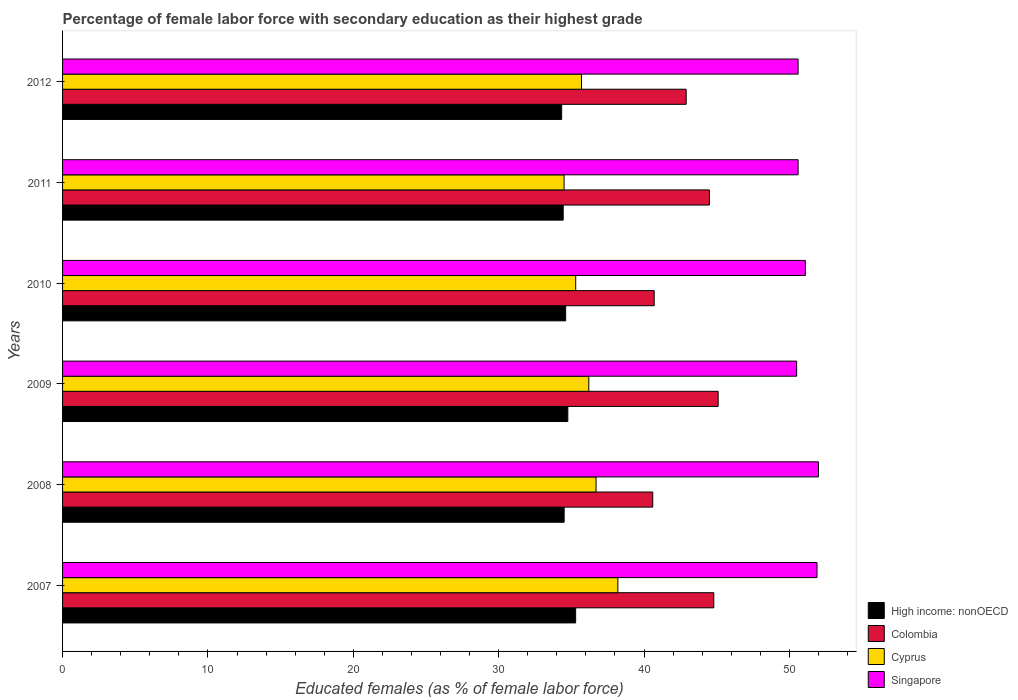How many different coloured bars are there?
Make the answer very short. 4. How many groups of bars are there?
Offer a very short reply. 6. Are the number of bars on each tick of the Y-axis equal?
Provide a short and direct response. Yes. How many bars are there on the 3rd tick from the top?
Your response must be concise. 4. What is the percentage of female labor force with secondary education in Colombia in 2011?
Keep it short and to the point. 44.5. Across all years, what is the maximum percentage of female labor force with secondary education in Colombia?
Provide a short and direct response. 45.1. Across all years, what is the minimum percentage of female labor force with secondary education in High income: nonOECD?
Provide a succinct answer. 34.33. In which year was the percentage of female labor force with secondary education in High income: nonOECD minimum?
Provide a short and direct response. 2012. What is the total percentage of female labor force with secondary education in Cyprus in the graph?
Your response must be concise. 216.6. What is the difference between the percentage of female labor force with secondary education in Cyprus in 2011 and that in 2012?
Offer a very short reply. -1.2. What is the difference between the percentage of female labor force with secondary education in Colombia in 2011 and the percentage of female labor force with secondary education in Singapore in 2007?
Your answer should be compact. -7.4. What is the average percentage of female labor force with secondary education in Colombia per year?
Your response must be concise. 43.1. In the year 2009, what is the difference between the percentage of female labor force with secondary education in Singapore and percentage of female labor force with secondary education in High income: nonOECD?
Ensure brevity in your answer.  15.74. What is the ratio of the percentage of female labor force with secondary education in High income: nonOECD in 2008 to that in 2012?
Your answer should be compact. 1. Is the difference between the percentage of female labor force with secondary education in Singapore in 2009 and 2010 greater than the difference between the percentage of female labor force with secondary education in High income: nonOECD in 2009 and 2010?
Offer a terse response. No. What is the difference between the highest and the second highest percentage of female labor force with secondary education in High income: nonOECD?
Provide a succinct answer. 0.54. In how many years, is the percentage of female labor force with secondary education in Colombia greater than the average percentage of female labor force with secondary education in Colombia taken over all years?
Your answer should be very brief. 3. Is it the case that in every year, the sum of the percentage of female labor force with secondary education in High income: nonOECD and percentage of female labor force with secondary education in Colombia is greater than the sum of percentage of female labor force with secondary education in Cyprus and percentage of female labor force with secondary education in Singapore?
Your response must be concise. Yes. What does the 3rd bar from the top in 2009 represents?
Ensure brevity in your answer.  Colombia. What does the 4th bar from the bottom in 2012 represents?
Give a very brief answer. Singapore. Is it the case that in every year, the sum of the percentage of female labor force with secondary education in Singapore and percentage of female labor force with secondary education in Colombia is greater than the percentage of female labor force with secondary education in Cyprus?
Ensure brevity in your answer.  Yes. How many bars are there?
Offer a very short reply. 24. Does the graph contain any zero values?
Your answer should be very brief. No. Does the graph contain grids?
Offer a terse response. No. How many legend labels are there?
Offer a very short reply. 4. What is the title of the graph?
Keep it short and to the point. Percentage of female labor force with secondary education as their highest grade. Does "Isle of Man" appear as one of the legend labels in the graph?
Provide a short and direct response. No. What is the label or title of the X-axis?
Provide a succinct answer. Educated females (as % of female labor force). What is the label or title of the Y-axis?
Your answer should be very brief. Years. What is the Educated females (as % of female labor force) of High income: nonOECD in 2007?
Give a very brief answer. 35.3. What is the Educated females (as % of female labor force) in Colombia in 2007?
Offer a very short reply. 44.8. What is the Educated females (as % of female labor force) in Cyprus in 2007?
Provide a short and direct response. 38.2. What is the Educated females (as % of female labor force) in Singapore in 2007?
Ensure brevity in your answer.  51.9. What is the Educated females (as % of female labor force) of High income: nonOECD in 2008?
Offer a terse response. 34.51. What is the Educated females (as % of female labor force) of Colombia in 2008?
Provide a short and direct response. 40.6. What is the Educated females (as % of female labor force) in Cyprus in 2008?
Offer a terse response. 36.7. What is the Educated females (as % of female labor force) of Singapore in 2008?
Your answer should be compact. 52. What is the Educated females (as % of female labor force) in High income: nonOECD in 2009?
Give a very brief answer. 34.76. What is the Educated females (as % of female labor force) of Colombia in 2009?
Provide a succinct answer. 45.1. What is the Educated females (as % of female labor force) of Cyprus in 2009?
Your response must be concise. 36.2. What is the Educated females (as % of female labor force) in Singapore in 2009?
Keep it short and to the point. 50.5. What is the Educated females (as % of female labor force) of High income: nonOECD in 2010?
Give a very brief answer. 34.61. What is the Educated females (as % of female labor force) of Colombia in 2010?
Offer a terse response. 40.7. What is the Educated females (as % of female labor force) in Cyprus in 2010?
Your answer should be very brief. 35.3. What is the Educated females (as % of female labor force) in Singapore in 2010?
Keep it short and to the point. 51.1. What is the Educated females (as % of female labor force) in High income: nonOECD in 2011?
Ensure brevity in your answer.  34.44. What is the Educated females (as % of female labor force) in Colombia in 2011?
Offer a very short reply. 44.5. What is the Educated females (as % of female labor force) of Cyprus in 2011?
Offer a very short reply. 34.5. What is the Educated females (as % of female labor force) in Singapore in 2011?
Your response must be concise. 50.6. What is the Educated females (as % of female labor force) in High income: nonOECD in 2012?
Offer a very short reply. 34.33. What is the Educated females (as % of female labor force) in Colombia in 2012?
Provide a succinct answer. 42.9. What is the Educated females (as % of female labor force) of Cyprus in 2012?
Provide a short and direct response. 35.7. What is the Educated females (as % of female labor force) in Singapore in 2012?
Make the answer very short. 50.6. Across all years, what is the maximum Educated females (as % of female labor force) of High income: nonOECD?
Your answer should be very brief. 35.3. Across all years, what is the maximum Educated females (as % of female labor force) in Colombia?
Give a very brief answer. 45.1. Across all years, what is the maximum Educated females (as % of female labor force) of Cyprus?
Your answer should be compact. 38.2. Across all years, what is the maximum Educated females (as % of female labor force) in Singapore?
Offer a terse response. 52. Across all years, what is the minimum Educated females (as % of female labor force) in High income: nonOECD?
Ensure brevity in your answer.  34.33. Across all years, what is the minimum Educated females (as % of female labor force) of Colombia?
Provide a succinct answer. 40.6. Across all years, what is the minimum Educated females (as % of female labor force) in Cyprus?
Make the answer very short. 34.5. Across all years, what is the minimum Educated females (as % of female labor force) of Singapore?
Make the answer very short. 50.5. What is the total Educated females (as % of female labor force) in High income: nonOECD in the graph?
Make the answer very short. 207.94. What is the total Educated females (as % of female labor force) of Colombia in the graph?
Your answer should be very brief. 258.6. What is the total Educated females (as % of female labor force) in Cyprus in the graph?
Your response must be concise. 216.6. What is the total Educated females (as % of female labor force) of Singapore in the graph?
Give a very brief answer. 306.7. What is the difference between the Educated females (as % of female labor force) in High income: nonOECD in 2007 and that in 2008?
Your answer should be very brief. 0.79. What is the difference between the Educated females (as % of female labor force) of Cyprus in 2007 and that in 2008?
Provide a short and direct response. 1.5. What is the difference between the Educated females (as % of female labor force) of Singapore in 2007 and that in 2008?
Give a very brief answer. -0.1. What is the difference between the Educated females (as % of female labor force) of High income: nonOECD in 2007 and that in 2009?
Provide a short and direct response. 0.54. What is the difference between the Educated females (as % of female labor force) in Cyprus in 2007 and that in 2009?
Offer a very short reply. 2. What is the difference between the Educated females (as % of female labor force) of High income: nonOECD in 2007 and that in 2010?
Give a very brief answer. 0.69. What is the difference between the Educated females (as % of female labor force) of Colombia in 2007 and that in 2010?
Offer a very short reply. 4.1. What is the difference between the Educated females (as % of female labor force) of Cyprus in 2007 and that in 2010?
Provide a short and direct response. 2.9. What is the difference between the Educated females (as % of female labor force) of High income: nonOECD in 2007 and that in 2011?
Make the answer very short. 0.86. What is the difference between the Educated females (as % of female labor force) of High income: nonOECD in 2007 and that in 2012?
Keep it short and to the point. 0.96. What is the difference between the Educated females (as % of female labor force) in Colombia in 2007 and that in 2012?
Your answer should be very brief. 1.9. What is the difference between the Educated females (as % of female labor force) of High income: nonOECD in 2008 and that in 2009?
Ensure brevity in your answer.  -0.25. What is the difference between the Educated females (as % of female labor force) in Colombia in 2008 and that in 2009?
Offer a very short reply. -4.5. What is the difference between the Educated females (as % of female labor force) in Cyprus in 2008 and that in 2009?
Offer a very short reply. 0.5. What is the difference between the Educated females (as % of female labor force) in High income: nonOECD in 2008 and that in 2010?
Provide a succinct answer. -0.11. What is the difference between the Educated females (as % of female labor force) in Colombia in 2008 and that in 2010?
Your answer should be very brief. -0.1. What is the difference between the Educated females (as % of female labor force) in Singapore in 2008 and that in 2010?
Offer a very short reply. 0.9. What is the difference between the Educated females (as % of female labor force) in High income: nonOECD in 2008 and that in 2011?
Provide a succinct answer. 0.07. What is the difference between the Educated females (as % of female labor force) of Colombia in 2008 and that in 2011?
Your response must be concise. -3.9. What is the difference between the Educated females (as % of female labor force) in Singapore in 2008 and that in 2011?
Provide a succinct answer. 1.4. What is the difference between the Educated females (as % of female labor force) in High income: nonOECD in 2008 and that in 2012?
Ensure brevity in your answer.  0.17. What is the difference between the Educated females (as % of female labor force) of Colombia in 2008 and that in 2012?
Offer a very short reply. -2.3. What is the difference between the Educated females (as % of female labor force) of Cyprus in 2008 and that in 2012?
Offer a terse response. 1. What is the difference between the Educated females (as % of female labor force) of Singapore in 2008 and that in 2012?
Provide a short and direct response. 1.4. What is the difference between the Educated females (as % of female labor force) of High income: nonOECD in 2009 and that in 2010?
Provide a short and direct response. 0.15. What is the difference between the Educated females (as % of female labor force) in Colombia in 2009 and that in 2010?
Offer a very short reply. 4.4. What is the difference between the Educated females (as % of female labor force) in Cyprus in 2009 and that in 2010?
Your answer should be compact. 0.9. What is the difference between the Educated females (as % of female labor force) in High income: nonOECD in 2009 and that in 2011?
Provide a succinct answer. 0.32. What is the difference between the Educated females (as % of female labor force) of Colombia in 2009 and that in 2011?
Your answer should be very brief. 0.6. What is the difference between the Educated females (as % of female labor force) of Cyprus in 2009 and that in 2011?
Offer a terse response. 1.7. What is the difference between the Educated females (as % of female labor force) of High income: nonOECD in 2009 and that in 2012?
Your answer should be very brief. 0.42. What is the difference between the Educated females (as % of female labor force) of Colombia in 2009 and that in 2012?
Offer a terse response. 2.2. What is the difference between the Educated females (as % of female labor force) of Cyprus in 2009 and that in 2012?
Keep it short and to the point. 0.5. What is the difference between the Educated females (as % of female labor force) of Singapore in 2009 and that in 2012?
Give a very brief answer. -0.1. What is the difference between the Educated females (as % of female labor force) in High income: nonOECD in 2010 and that in 2011?
Provide a short and direct response. 0.17. What is the difference between the Educated females (as % of female labor force) in High income: nonOECD in 2010 and that in 2012?
Offer a terse response. 0.28. What is the difference between the Educated females (as % of female labor force) in High income: nonOECD in 2011 and that in 2012?
Give a very brief answer. 0.11. What is the difference between the Educated females (as % of female labor force) of Singapore in 2011 and that in 2012?
Give a very brief answer. 0. What is the difference between the Educated females (as % of female labor force) in High income: nonOECD in 2007 and the Educated females (as % of female labor force) in Colombia in 2008?
Your answer should be very brief. -5.3. What is the difference between the Educated females (as % of female labor force) of High income: nonOECD in 2007 and the Educated females (as % of female labor force) of Cyprus in 2008?
Your answer should be very brief. -1.4. What is the difference between the Educated females (as % of female labor force) of High income: nonOECD in 2007 and the Educated females (as % of female labor force) of Singapore in 2008?
Ensure brevity in your answer.  -16.7. What is the difference between the Educated females (as % of female labor force) of Colombia in 2007 and the Educated females (as % of female labor force) of Singapore in 2008?
Provide a succinct answer. -7.2. What is the difference between the Educated females (as % of female labor force) of Cyprus in 2007 and the Educated females (as % of female labor force) of Singapore in 2008?
Keep it short and to the point. -13.8. What is the difference between the Educated females (as % of female labor force) in High income: nonOECD in 2007 and the Educated females (as % of female labor force) in Colombia in 2009?
Provide a succinct answer. -9.8. What is the difference between the Educated females (as % of female labor force) in High income: nonOECD in 2007 and the Educated females (as % of female labor force) in Cyprus in 2009?
Make the answer very short. -0.9. What is the difference between the Educated females (as % of female labor force) of High income: nonOECD in 2007 and the Educated females (as % of female labor force) of Singapore in 2009?
Your answer should be very brief. -15.2. What is the difference between the Educated females (as % of female labor force) in Colombia in 2007 and the Educated females (as % of female labor force) in Cyprus in 2009?
Ensure brevity in your answer.  8.6. What is the difference between the Educated females (as % of female labor force) of Colombia in 2007 and the Educated females (as % of female labor force) of Singapore in 2009?
Ensure brevity in your answer.  -5.7. What is the difference between the Educated females (as % of female labor force) of High income: nonOECD in 2007 and the Educated females (as % of female labor force) of Colombia in 2010?
Your answer should be compact. -5.4. What is the difference between the Educated females (as % of female labor force) in High income: nonOECD in 2007 and the Educated females (as % of female labor force) in Cyprus in 2010?
Offer a terse response. -0. What is the difference between the Educated females (as % of female labor force) of High income: nonOECD in 2007 and the Educated females (as % of female labor force) of Singapore in 2010?
Your response must be concise. -15.8. What is the difference between the Educated females (as % of female labor force) of Colombia in 2007 and the Educated females (as % of female labor force) of Cyprus in 2010?
Offer a terse response. 9.5. What is the difference between the Educated females (as % of female labor force) of High income: nonOECD in 2007 and the Educated females (as % of female labor force) of Colombia in 2011?
Your response must be concise. -9.2. What is the difference between the Educated females (as % of female labor force) of High income: nonOECD in 2007 and the Educated females (as % of female labor force) of Cyprus in 2011?
Give a very brief answer. 0.8. What is the difference between the Educated females (as % of female labor force) of High income: nonOECD in 2007 and the Educated females (as % of female labor force) of Singapore in 2011?
Keep it short and to the point. -15.3. What is the difference between the Educated females (as % of female labor force) in Colombia in 2007 and the Educated females (as % of female labor force) in Cyprus in 2011?
Keep it short and to the point. 10.3. What is the difference between the Educated females (as % of female labor force) in Colombia in 2007 and the Educated females (as % of female labor force) in Singapore in 2011?
Your response must be concise. -5.8. What is the difference between the Educated females (as % of female labor force) of High income: nonOECD in 2007 and the Educated females (as % of female labor force) of Colombia in 2012?
Offer a terse response. -7.6. What is the difference between the Educated females (as % of female labor force) of High income: nonOECD in 2007 and the Educated females (as % of female labor force) of Cyprus in 2012?
Provide a short and direct response. -0.4. What is the difference between the Educated females (as % of female labor force) in High income: nonOECD in 2007 and the Educated females (as % of female labor force) in Singapore in 2012?
Offer a very short reply. -15.3. What is the difference between the Educated females (as % of female labor force) of Colombia in 2007 and the Educated females (as % of female labor force) of Cyprus in 2012?
Keep it short and to the point. 9.1. What is the difference between the Educated females (as % of female labor force) of High income: nonOECD in 2008 and the Educated females (as % of female labor force) of Colombia in 2009?
Offer a terse response. -10.59. What is the difference between the Educated females (as % of female labor force) of High income: nonOECD in 2008 and the Educated females (as % of female labor force) of Cyprus in 2009?
Make the answer very short. -1.69. What is the difference between the Educated females (as % of female labor force) in High income: nonOECD in 2008 and the Educated females (as % of female labor force) in Singapore in 2009?
Your response must be concise. -15.99. What is the difference between the Educated females (as % of female labor force) in Colombia in 2008 and the Educated females (as % of female labor force) in Singapore in 2009?
Provide a short and direct response. -9.9. What is the difference between the Educated females (as % of female labor force) of High income: nonOECD in 2008 and the Educated females (as % of female labor force) of Colombia in 2010?
Your response must be concise. -6.19. What is the difference between the Educated females (as % of female labor force) of High income: nonOECD in 2008 and the Educated females (as % of female labor force) of Cyprus in 2010?
Offer a very short reply. -0.79. What is the difference between the Educated females (as % of female labor force) in High income: nonOECD in 2008 and the Educated females (as % of female labor force) in Singapore in 2010?
Give a very brief answer. -16.59. What is the difference between the Educated females (as % of female labor force) of Cyprus in 2008 and the Educated females (as % of female labor force) of Singapore in 2010?
Your response must be concise. -14.4. What is the difference between the Educated females (as % of female labor force) of High income: nonOECD in 2008 and the Educated females (as % of female labor force) of Colombia in 2011?
Your answer should be very brief. -9.99. What is the difference between the Educated females (as % of female labor force) in High income: nonOECD in 2008 and the Educated females (as % of female labor force) in Cyprus in 2011?
Keep it short and to the point. 0.01. What is the difference between the Educated females (as % of female labor force) in High income: nonOECD in 2008 and the Educated females (as % of female labor force) in Singapore in 2011?
Provide a short and direct response. -16.09. What is the difference between the Educated females (as % of female labor force) of High income: nonOECD in 2008 and the Educated females (as % of female labor force) of Colombia in 2012?
Your response must be concise. -8.39. What is the difference between the Educated females (as % of female labor force) of High income: nonOECD in 2008 and the Educated females (as % of female labor force) of Cyprus in 2012?
Ensure brevity in your answer.  -1.19. What is the difference between the Educated females (as % of female labor force) in High income: nonOECD in 2008 and the Educated females (as % of female labor force) in Singapore in 2012?
Keep it short and to the point. -16.09. What is the difference between the Educated females (as % of female labor force) of Colombia in 2008 and the Educated females (as % of female labor force) of Cyprus in 2012?
Give a very brief answer. 4.9. What is the difference between the Educated females (as % of female labor force) in High income: nonOECD in 2009 and the Educated females (as % of female labor force) in Colombia in 2010?
Your response must be concise. -5.94. What is the difference between the Educated females (as % of female labor force) in High income: nonOECD in 2009 and the Educated females (as % of female labor force) in Cyprus in 2010?
Keep it short and to the point. -0.54. What is the difference between the Educated females (as % of female labor force) of High income: nonOECD in 2009 and the Educated females (as % of female labor force) of Singapore in 2010?
Your answer should be compact. -16.34. What is the difference between the Educated females (as % of female labor force) of Cyprus in 2009 and the Educated females (as % of female labor force) of Singapore in 2010?
Your answer should be compact. -14.9. What is the difference between the Educated females (as % of female labor force) of High income: nonOECD in 2009 and the Educated females (as % of female labor force) of Colombia in 2011?
Keep it short and to the point. -9.74. What is the difference between the Educated females (as % of female labor force) of High income: nonOECD in 2009 and the Educated females (as % of female labor force) of Cyprus in 2011?
Provide a succinct answer. 0.26. What is the difference between the Educated females (as % of female labor force) in High income: nonOECD in 2009 and the Educated females (as % of female labor force) in Singapore in 2011?
Make the answer very short. -15.84. What is the difference between the Educated females (as % of female labor force) in Cyprus in 2009 and the Educated females (as % of female labor force) in Singapore in 2011?
Your response must be concise. -14.4. What is the difference between the Educated females (as % of female labor force) of High income: nonOECD in 2009 and the Educated females (as % of female labor force) of Colombia in 2012?
Offer a very short reply. -8.14. What is the difference between the Educated females (as % of female labor force) in High income: nonOECD in 2009 and the Educated females (as % of female labor force) in Cyprus in 2012?
Give a very brief answer. -0.94. What is the difference between the Educated females (as % of female labor force) in High income: nonOECD in 2009 and the Educated females (as % of female labor force) in Singapore in 2012?
Provide a succinct answer. -15.84. What is the difference between the Educated females (as % of female labor force) of Colombia in 2009 and the Educated females (as % of female labor force) of Cyprus in 2012?
Your answer should be compact. 9.4. What is the difference between the Educated females (as % of female labor force) of Cyprus in 2009 and the Educated females (as % of female labor force) of Singapore in 2012?
Provide a succinct answer. -14.4. What is the difference between the Educated females (as % of female labor force) in High income: nonOECD in 2010 and the Educated females (as % of female labor force) in Colombia in 2011?
Make the answer very short. -9.89. What is the difference between the Educated females (as % of female labor force) in High income: nonOECD in 2010 and the Educated females (as % of female labor force) in Cyprus in 2011?
Give a very brief answer. 0.11. What is the difference between the Educated females (as % of female labor force) in High income: nonOECD in 2010 and the Educated females (as % of female labor force) in Singapore in 2011?
Your answer should be very brief. -15.99. What is the difference between the Educated females (as % of female labor force) of Colombia in 2010 and the Educated females (as % of female labor force) of Cyprus in 2011?
Offer a very short reply. 6.2. What is the difference between the Educated females (as % of female labor force) in Colombia in 2010 and the Educated females (as % of female labor force) in Singapore in 2011?
Your response must be concise. -9.9. What is the difference between the Educated females (as % of female labor force) in Cyprus in 2010 and the Educated females (as % of female labor force) in Singapore in 2011?
Give a very brief answer. -15.3. What is the difference between the Educated females (as % of female labor force) in High income: nonOECD in 2010 and the Educated females (as % of female labor force) in Colombia in 2012?
Ensure brevity in your answer.  -8.29. What is the difference between the Educated females (as % of female labor force) of High income: nonOECD in 2010 and the Educated females (as % of female labor force) of Cyprus in 2012?
Provide a succinct answer. -1.09. What is the difference between the Educated females (as % of female labor force) in High income: nonOECD in 2010 and the Educated females (as % of female labor force) in Singapore in 2012?
Provide a succinct answer. -15.99. What is the difference between the Educated females (as % of female labor force) of Colombia in 2010 and the Educated females (as % of female labor force) of Singapore in 2012?
Your answer should be very brief. -9.9. What is the difference between the Educated females (as % of female labor force) of Cyprus in 2010 and the Educated females (as % of female labor force) of Singapore in 2012?
Your answer should be very brief. -15.3. What is the difference between the Educated females (as % of female labor force) in High income: nonOECD in 2011 and the Educated females (as % of female labor force) in Colombia in 2012?
Offer a terse response. -8.46. What is the difference between the Educated females (as % of female labor force) in High income: nonOECD in 2011 and the Educated females (as % of female labor force) in Cyprus in 2012?
Provide a succinct answer. -1.26. What is the difference between the Educated females (as % of female labor force) in High income: nonOECD in 2011 and the Educated females (as % of female labor force) in Singapore in 2012?
Your answer should be compact. -16.16. What is the difference between the Educated females (as % of female labor force) in Colombia in 2011 and the Educated females (as % of female labor force) in Singapore in 2012?
Offer a very short reply. -6.1. What is the difference between the Educated females (as % of female labor force) in Cyprus in 2011 and the Educated females (as % of female labor force) in Singapore in 2012?
Ensure brevity in your answer.  -16.1. What is the average Educated females (as % of female labor force) in High income: nonOECD per year?
Ensure brevity in your answer.  34.66. What is the average Educated females (as % of female labor force) of Colombia per year?
Your answer should be very brief. 43.1. What is the average Educated females (as % of female labor force) in Cyprus per year?
Give a very brief answer. 36.1. What is the average Educated females (as % of female labor force) in Singapore per year?
Make the answer very short. 51.12. In the year 2007, what is the difference between the Educated females (as % of female labor force) in High income: nonOECD and Educated females (as % of female labor force) in Colombia?
Your answer should be compact. -9.5. In the year 2007, what is the difference between the Educated females (as % of female labor force) in High income: nonOECD and Educated females (as % of female labor force) in Cyprus?
Offer a terse response. -2.9. In the year 2007, what is the difference between the Educated females (as % of female labor force) in High income: nonOECD and Educated females (as % of female labor force) in Singapore?
Give a very brief answer. -16.6. In the year 2007, what is the difference between the Educated females (as % of female labor force) in Colombia and Educated females (as % of female labor force) in Singapore?
Offer a very short reply. -7.1. In the year 2007, what is the difference between the Educated females (as % of female labor force) in Cyprus and Educated females (as % of female labor force) in Singapore?
Your response must be concise. -13.7. In the year 2008, what is the difference between the Educated females (as % of female labor force) of High income: nonOECD and Educated females (as % of female labor force) of Colombia?
Your response must be concise. -6.09. In the year 2008, what is the difference between the Educated females (as % of female labor force) in High income: nonOECD and Educated females (as % of female labor force) in Cyprus?
Your answer should be very brief. -2.19. In the year 2008, what is the difference between the Educated females (as % of female labor force) in High income: nonOECD and Educated females (as % of female labor force) in Singapore?
Keep it short and to the point. -17.49. In the year 2008, what is the difference between the Educated females (as % of female labor force) in Colombia and Educated females (as % of female labor force) in Cyprus?
Offer a terse response. 3.9. In the year 2008, what is the difference between the Educated females (as % of female labor force) of Colombia and Educated females (as % of female labor force) of Singapore?
Ensure brevity in your answer.  -11.4. In the year 2008, what is the difference between the Educated females (as % of female labor force) in Cyprus and Educated females (as % of female labor force) in Singapore?
Provide a short and direct response. -15.3. In the year 2009, what is the difference between the Educated females (as % of female labor force) in High income: nonOECD and Educated females (as % of female labor force) in Colombia?
Your answer should be very brief. -10.34. In the year 2009, what is the difference between the Educated females (as % of female labor force) of High income: nonOECD and Educated females (as % of female labor force) of Cyprus?
Make the answer very short. -1.44. In the year 2009, what is the difference between the Educated females (as % of female labor force) in High income: nonOECD and Educated females (as % of female labor force) in Singapore?
Provide a succinct answer. -15.74. In the year 2009, what is the difference between the Educated females (as % of female labor force) of Colombia and Educated females (as % of female labor force) of Singapore?
Provide a succinct answer. -5.4. In the year 2009, what is the difference between the Educated females (as % of female labor force) in Cyprus and Educated females (as % of female labor force) in Singapore?
Your response must be concise. -14.3. In the year 2010, what is the difference between the Educated females (as % of female labor force) in High income: nonOECD and Educated females (as % of female labor force) in Colombia?
Your response must be concise. -6.09. In the year 2010, what is the difference between the Educated females (as % of female labor force) in High income: nonOECD and Educated females (as % of female labor force) in Cyprus?
Your response must be concise. -0.69. In the year 2010, what is the difference between the Educated females (as % of female labor force) in High income: nonOECD and Educated females (as % of female labor force) in Singapore?
Offer a terse response. -16.49. In the year 2010, what is the difference between the Educated females (as % of female labor force) in Cyprus and Educated females (as % of female labor force) in Singapore?
Offer a very short reply. -15.8. In the year 2011, what is the difference between the Educated females (as % of female labor force) of High income: nonOECD and Educated females (as % of female labor force) of Colombia?
Ensure brevity in your answer.  -10.06. In the year 2011, what is the difference between the Educated females (as % of female labor force) in High income: nonOECD and Educated females (as % of female labor force) in Cyprus?
Offer a terse response. -0.06. In the year 2011, what is the difference between the Educated females (as % of female labor force) in High income: nonOECD and Educated females (as % of female labor force) in Singapore?
Provide a succinct answer. -16.16. In the year 2011, what is the difference between the Educated females (as % of female labor force) in Colombia and Educated females (as % of female labor force) in Cyprus?
Offer a very short reply. 10. In the year 2011, what is the difference between the Educated females (as % of female labor force) in Cyprus and Educated females (as % of female labor force) in Singapore?
Keep it short and to the point. -16.1. In the year 2012, what is the difference between the Educated females (as % of female labor force) of High income: nonOECD and Educated females (as % of female labor force) of Colombia?
Offer a very short reply. -8.57. In the year 2012, what is the difference between the Educated females (as % of female labor force) of High income: nonOECD and Educated females (as % of female labor force) of Cyprus?
Your answer should be very brief. -1.37. In the year 2012, what is the difference between the Educated females (as % of female labor force) of High income: nonOECD and Educated females (as % of female labor force) of Singapore?
Your answer should be compact. -16.27. In the year 2012, what is the difference between the Educated females (as % of female labor force) in Colombia and Educated females (as % of female labor force) in Singapore?
Your answer should be very brief. -7.7. In the year 2012, what is the difference between the Educated females (as % of female labor force) of Cyprus and Educated females (as % of female labor force) of Singapore?
Keep it short and to the point. -14.9. What is the ratio of the Educated females (as % of female labor force) of High income: nonOECD in 2007 to that in 2008?
Give a very brief answer. 1.02. What is the ratio of the Educated females (as % of female labor force) of Colombia in 2007 to that in 2008?
Offer a terse response. 1.1. What is the ratio of the Educated females (as % of female labor force) of Cyprus in 2007 to that in 2008?
Offer a terse response. 1.04. What is the ratio of the Educated females (as % of female labor force) of High income: nonOECD in 2007 to that in 2009?
Offer a very short reply. 1.02. What is the ratio of the Educated females (as % of female labor force) in Colombia in 2007 to that in 2009?
Your answer should be compact. 0.99. What is the ratio of the Educated females (as % of female labor force) of Cyprus in 2007 to that in 2009?
Your response must be concise. 1.06. What is the ratio of the Educated females (as % of female labor force) of Singapore in 2007 to that in 2009?
Make the answer very short. 1.03. What is the ratio of the Educated females (as % of female labor force) of High income: nonOECD in 2007 to that in 2010?
Provide a succinct answer. 1.02. What is the ratio of the Educated females (as % of female labor force) of Colombia in 2007 to that in 2010?
Ensure brevity in your answer.  1.1. What is the ratio of the Educated females (as % of female labor force) in Cyprus in 2007 to that in 2010?
Provide a succinct answer. 1.08. What is the ratio of the Educated females (as % of female labor force) of Singapore in 2007 to that in 2010?
Your response must be concise. 1.02. What is the ratio of the Educated females (as % of female labor force) in High income: nonOECD in 2007 to that in 2011?
Offer a very short reply. 1.02. What is the ratio of the Educated females (as % of female labor force) in Cyprus in 2007 to that in 2011?
Offer a terse response. 1.11. What is the ratio of the Educated females (as % of female labor force) in Singapore in 2007 to that in 2011?
Your answer should be very brief. 1.03. What is the ratio of the Educated females (as % of female labor force) of High income: nonOECD in 2007 to that in 2012?
Your answer should be very brief. 1.03. What is the ratio of the Educated females (as % of female labor force) of Colombia in 2007 to that in 2012?
Offer a very short reply. 1.04. What is the ratio of the Educated females (as % of female labor force) of Cyprus in 2007 to that in 2012?
Offer a very short reply. 1.07. What is the ratio of the Educated females (as % of female labor force) of Singapore in 2007 to that in 2012?
Keep it short and to the point. 1.03. What is the ratio of the Educated females (as % of female labor force) in Colombia in 2008 to that in 2009?
Keep it short and to the point. 0.9. What is the ratio of the Educated females (as % of female labor force) in Cyprus in 2008 to that in 2009?
Give a very brief answer. 1.01. What is the ratio of the Educated females (as % of female labor force) in Singapore in 2008 to that in 2009?
Give a very brief answer. 1.03. What is the ratio of the Educated females (as % of female labor force) in Colombia in 2008 to that in 2010?
Ensure brevity in your answer.  1. What is the ratio of the Educated females (as % of female labor force) of Cyprus in 2008 to that in 2010?
Keep it short and to the point. 1.04. What is the ratio of the Educated females (as % of female labor force) of Singapore in 2008 to that in 2010?
Your answer should be compact. 1.02. What is the ratio of the Educated females (as % of female labor force) in High income: nonOECD in 2008 to that in 2011?
Make the answer very short. 1. What is the ratio of the Educated females (as % of female labor force) in Colombia in 2008 to that in 2011?
Keep it short and to the point. 0.91. What is the ratio of the Educated females (as % of female labor force) of Cyprus in 2008 to that in 2011?
Make the answer very short. 1.06. What is the ratio of the Educated females (as % of female labor force) in Singapore in 2008 to that in 2011?
Your answer should be compact. 1.03. What is the ratio of the Educated females (as % of female labor force) in Colombia in 2008 to that in 2012?
Keep it short and to the point. 0.95. What is the ratio of the Educated females (as % of female labor force) of Cyprus in 2008 to that in 2012?
Make the answer very short. 1.03. What is the ratio of the Educated females (as % of female labor force) in Singapore in 2008 to that in 2012?
Keep it short and to the point. 1.03. What is the ratio of the Educated females (as % of female labor force) of Colombia in 2009 to that in 2010?
Offer a terse response. 1.11. What is the ratio of the Educated females (as % of female labor force) of Cyprus in 2009 to that in 2010?
Offer a terse response. 1.03. What is the ratio of the Educated females (as % of female labor force) in Singapore in 2009 to that in 2010?
Give a very brief answer. 0.99. What is the ratio of the Educated females (as % of female labor force) in High income: nonOECD in 2009 to that in 2011?
Your answer should be very brief. 1.01. What is the ratio of the Educated females (as % of female labor force) of Colombia in 2009 to that in 2011?
Make the answer very short. 1.01. What is the ratio of the Educated females (as % of female labor force) in Cyprus in 2009 to that in 2011?
Your response must be concise. 1.05. What is the ratio of the Educated females (as % of female labor force) of High income: nonOECD in 2009 to that in 2012?
Keep it short and to the point. 1.01. What is the ratio of the Educated females (as % of female labor force) in Colombia in 2009 to that in 2012?
Offer a very short reply. 1.05. What is the ratio of the Educated females (as % of female labor force) of Cyprus in 2009 to that in 2012?
Offer a terse response. 1.01. What is the ratio of the Educated females (as % of female labor force) of Singapore in 2009 to that in 2012?
Offer a terse response. 1. What is the ratio of the Educated females (as % of female labor force) in High income: nonOECD in 2010 to that in 2011?
Your response must be concise. 1. What is the ratio of the Educated females (as % of female labor force) of Colombia in 2010 to that in 2011?
Offer a terse response. 0.91. What is the ratio of the Educated females (as % of female labor force) in Cyprus in 2010 to that in 2011?
Make the answer very short. 1.02. What is the ratio of the Educated females (as % of female labor force) in Singapore in 2010 to that in 2011?
Ensure brevity in your answer.  1.01. What is the ratio of the Educated females (as % of female labor force) in High income: nonOECD in 2010 to that in 2012?
Keep it short and to the point. 1.01. What is the ratio of the Educated females (as % of female labor force) in Colombia in 2010 to that in 2012?
Your answer should be compact. 0.95. What is the ratio of the Educated females (as % of female labor force) in Singapore in 2010 to that in 2012?
Offer a very short reply. 1.01. What is the ratio of the Educated females (as % of female labor force) of Colombia in 2011 to that in 2012?
Provide a succinct answer. 1.04. What is the ratio of the Educated females (as % of female labor force) in Cyprus in 2011 to that in 2012?
Your response must be concise. 0.97. What is the ratio of the Educated females (as % of female labor force) in Singapore in 2011 to that in 2012?
Offer a very short reply. 1. What is the difference between the highest and the second highest Educated females (as % of female labor force) in High income: nonOECD?
Your response must be concise. 0.54. What is the difference between the highest and the second highest Educated females (as % of female labor force) of Cyprus?
Give a very brief answer. 1.5. What is the difference between the highest and the lowest Educated females (as % of female labor force) of High income: nonOECD?
Ensure brevity in your answer.  0.96. 